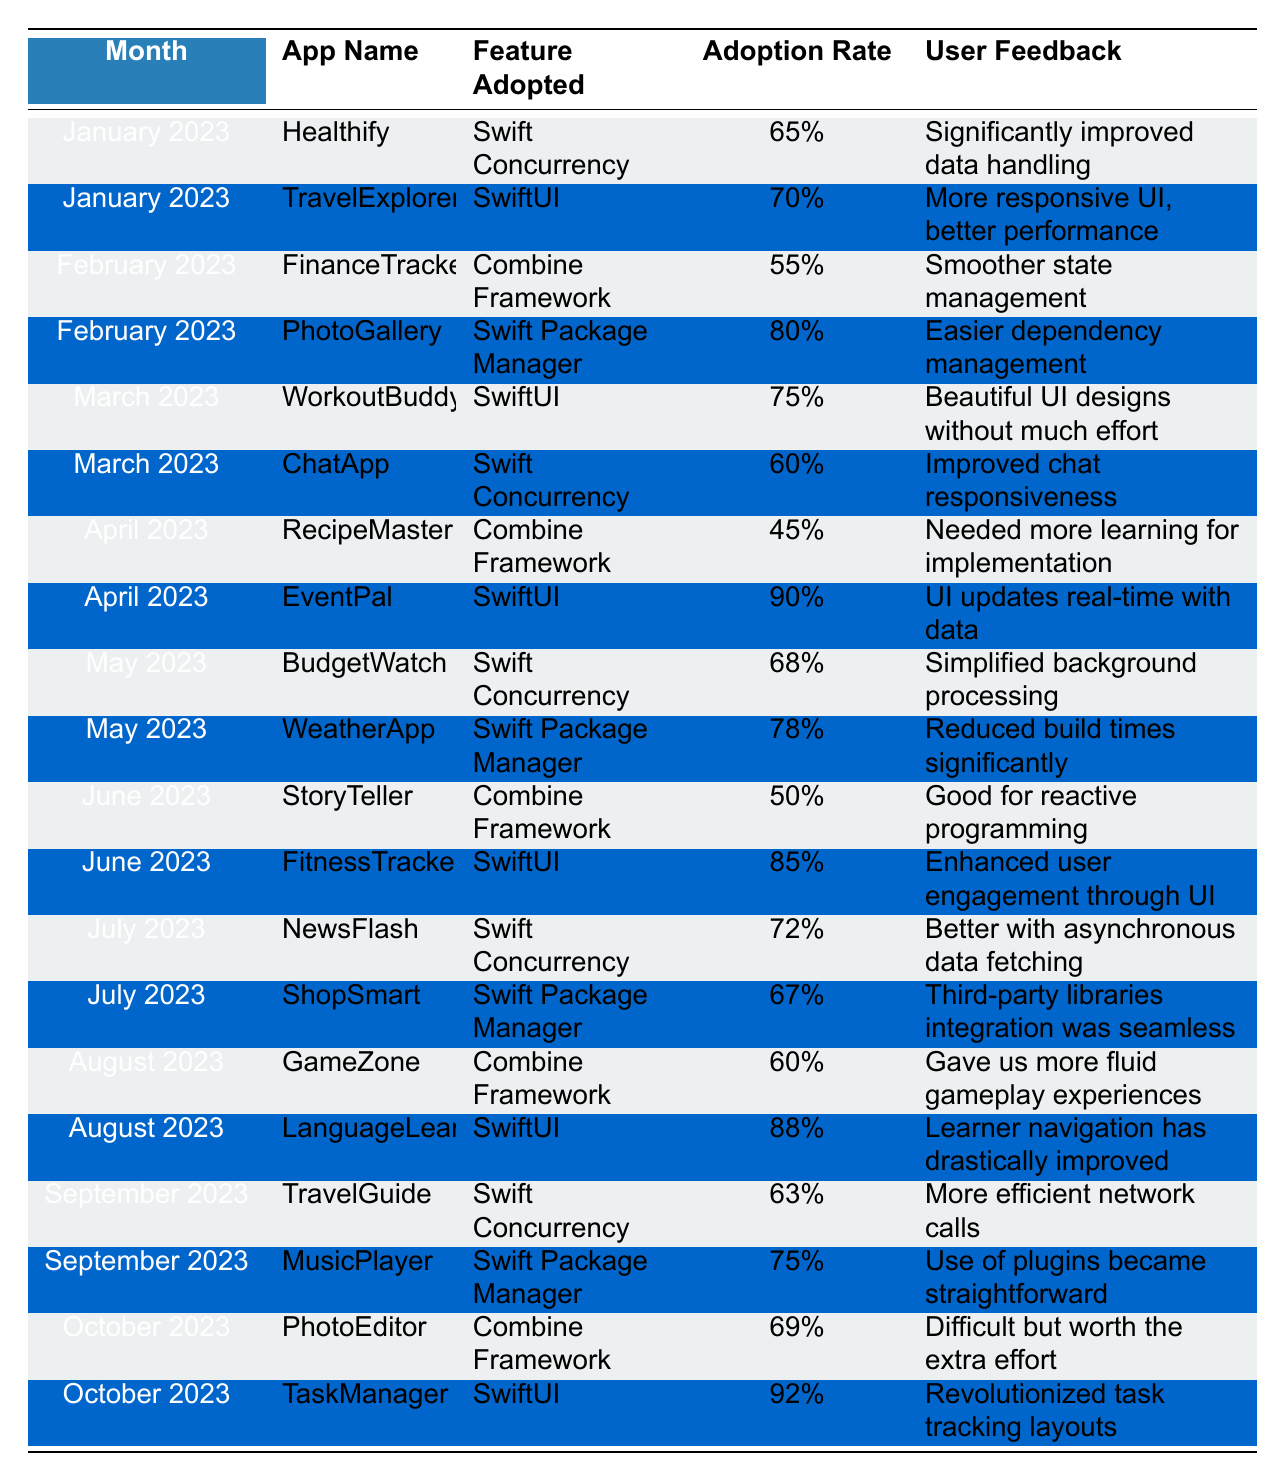What is the adoption rate of SwiftUI for the app EventPal in April 2023? Looking at the table, under the April 2023 section, the app EventPal has adopted SwiftUI with an adoption rate of 90%.
Answer: 90% Which month had the lowest adoption rate for the Combine Framework? Reviewing the table, the app RecipeMaster in April 2023 had the lowest adoption rate for the Combine Framework, which is 45%.
Answer: April 2023 What is the average adoption rate for Swift Concurrency across all the months presented? The adoption rates for Swift Concurrency are 65%, 60%, 68%, 72%, and 63%. Adding these values gives 65 + 60 + 68 + 72 + 63 = 328. There are 5 values, so the average is 328 / 5 = 65.6%.
Answer: 65.6% Did the app LanguageLearner have a higher adoption rate for SwiftUI compared to the adoption rate of Swift Concurrency for the app NewsFlash in July 2023? The adoption rate for SwiftUI in LanguageLearner is 88%, while the adoption rate for Swift Concurrency in NewsFlash is 72%. Since 88% is greater than 72%, the answer is yes.
Answer: Yes Which app had the highest adoption rate for SwiftUI in October 2023 and what percentage was it? Looking at the October 2023 section of the table, TaskManager had the highest adoption rate for SwiftUI, which is 92%.
Answer: TaskManager, 92% What is the overall trend of adoption rates for the Swift Package Manager from February to October 2023? The adoption rates for Swift Package Manager are 80% (February), 78% (May), 67% (July), and 75% (September). The trend shows a decline from February's 80% to May's 78%, followed by a decline to 67% in July, which then increases to 75% in September.
Answer: Declining with a slight increase in September How many apps adopted SwiftUI in June 2023 and what was the average adoption rate? In June 2023, FitnessTracker adopted SwiftUI with an adoption rate of 85%. Thus, there's only one app that adopted SwiftUI in June, so the average adoption rate is also 85%.
Answer: 1 app, 85% What user feedback was given for the app PhotoGallery after adopting the Swift Package Manager? According to the data, the user feedback for PhotoGallery after adopting the Swift Package Manager was, "Easier dependency management."
Answer: Easier dependency management Comparing the Combine Framework to SwiftUI, which framework had a higher average adoption rate across the months? The adoption rates for Combine Framework are 55%, 45%, 50%, 60%, and 69%. Summing these gives 55 + 45 + 50 + 60 + 69 = 279. The average for Combine is 279 / 5 = 55.8%. The adoption rates for SwiftUI are 70%, 75%, 90%, 85%, 88%, 92%. The sum is 70 + 75 + 90 + 85 + 88 + 92 = 500. The average is 500 / 6 = 83.3%. Since 83.3% is greater than 55.8%, SwiftUI has a higher average adoption rate.
Answer: SwiftUI, higher average rate 